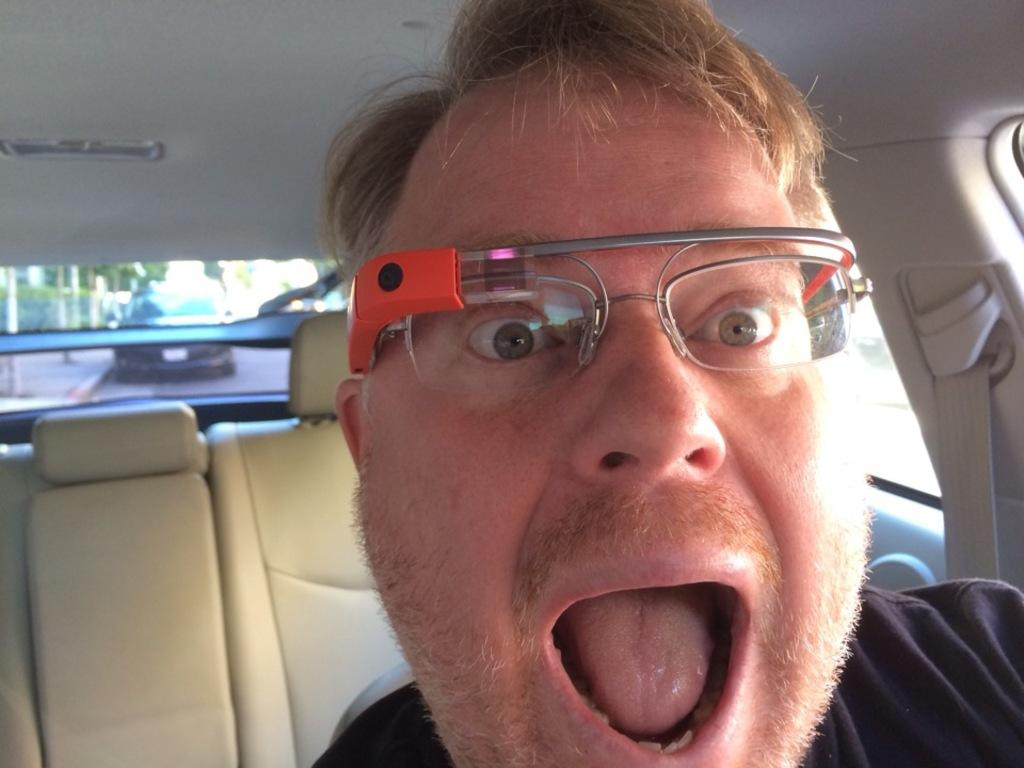What is the setting of the image? The image shows the inside view of a car. Can you describe the person in the car? There is a person in the car, and they are wearing spectacles. What type of guide is the person holding in the image? There is no guide visible in the image; it only shows the inside view of a car with a person wearing spectacles. 